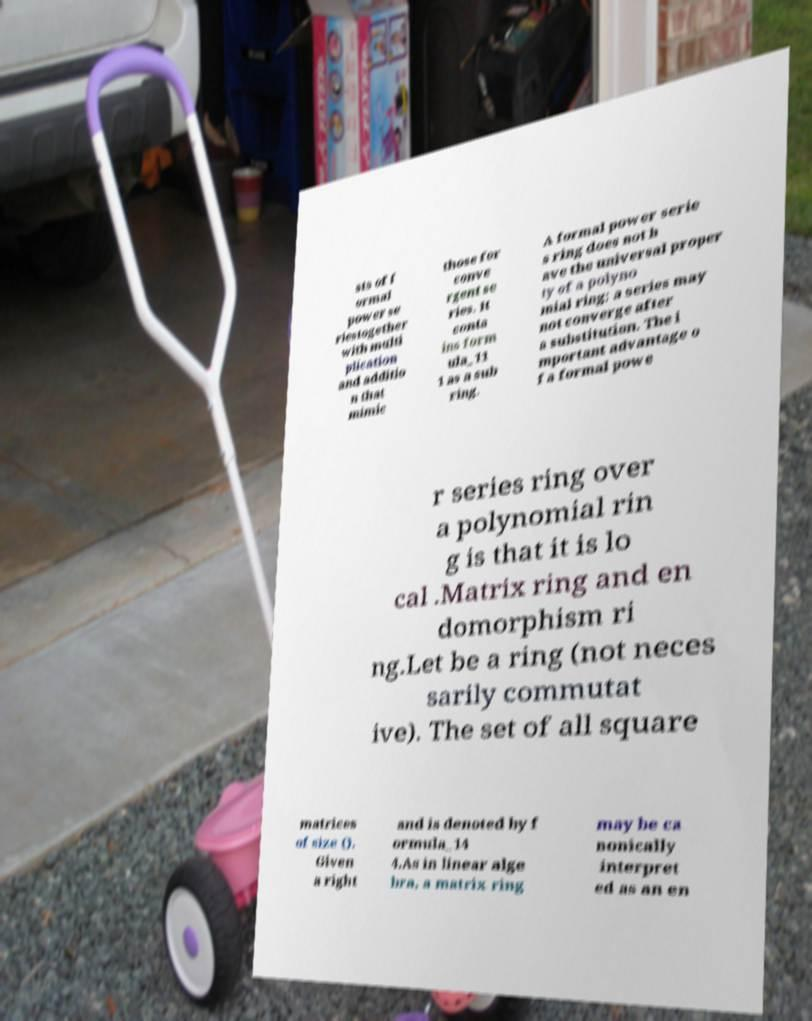Can you read and provide the text displayed in the image?This photo seems to have some interesting text. Can you extract and type it out for me? sts of f ormal power se riestogether with multi plication and additio n that mimic those for conve rgent se ries. It conta ins form ula_11 1 as a sub ring. A formal power serie s ring does not h ave the universal proper ty of a polyno mial ring; a series may not converge after a substitution. The i mportant advantage o f a formal powe r series ring over a polynomial rin g is that it is lo cal .Matrix ring and en domorphism ri ng.Let be a ring (not neces sarily commutat ive). The set of all square matrices of size (). Given a right and is denoted by f ormula_14 4.As in linear alge bra, a matrix ring may be ca nonically interpret ed as an en 